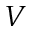<formula> <loc_0><loc_0><loc_500><loc_500>V</formula> 